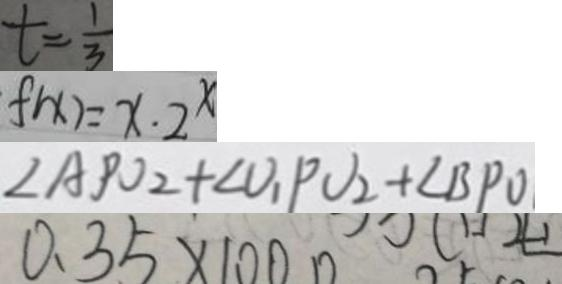Convert formula to latex. <formula><loc_0><loc_0><loc_500><loc_500>t = \frac { 1 } { 3 } 
 f ( x ) = x \cdot 2 ^ { x } 
 \angle A P O _ { 2 } + \angle v _ { 1 } P v _ { 2 } + \angle B P O 
 0 . 3 5 \times 1 0 0 0</formula> 